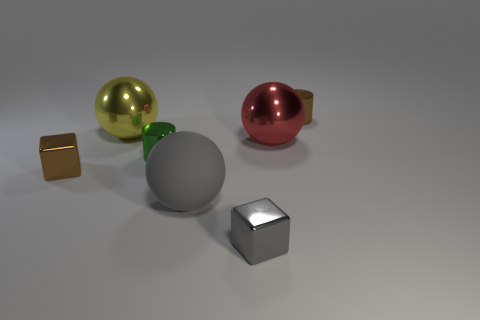Is the number of small brown cylinders that are in front of the gray metal block less than the number of big red objects that are left of the big matte object?
Your answer should be very brief. No. What is the color of the matte sphere?
Give a very brief answer. Gray. How many small cubes are the same color as the rubber ball?
Provide a short and direct response. 1. There is a red thing; are there any big yellow things in front of it?
Provide a short and direct response. No. Are there an equal number of small brown shiny cylinders in front of the gray block and tiny metallic cubes right of the big yellow thing?
Offer a terse response. No. Do the metal cube that is behind the tiny gray metallic thing and the cylinder in front of the small brown cylinder have the same size?
Offer a very short reply. Yes. There is a small brown object that is to the left of the small brown object that is behind the brown metallic object that is to the left of the small brown cylinder; what is its shape?
Give a very brief answer. Cube. Is there any other thing that is the same material as the red sphere?
Keep it short and to the point. Yes. What size is the brown metal thing that is the same shape as the small green metal object?
Offer a very short reply. Small. There is a metal object that is behind the red shiny thing and to the right of the tiny gray block; what is its color?
Provide a short and direct response. Brown. 